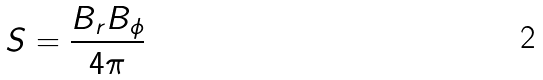Convert formula to latex. <formula><loc_0><loc_0><loc_500><loc_500>S = \frac { B _ { r } B _ { \phi } } { 4 \pi }</formula> 